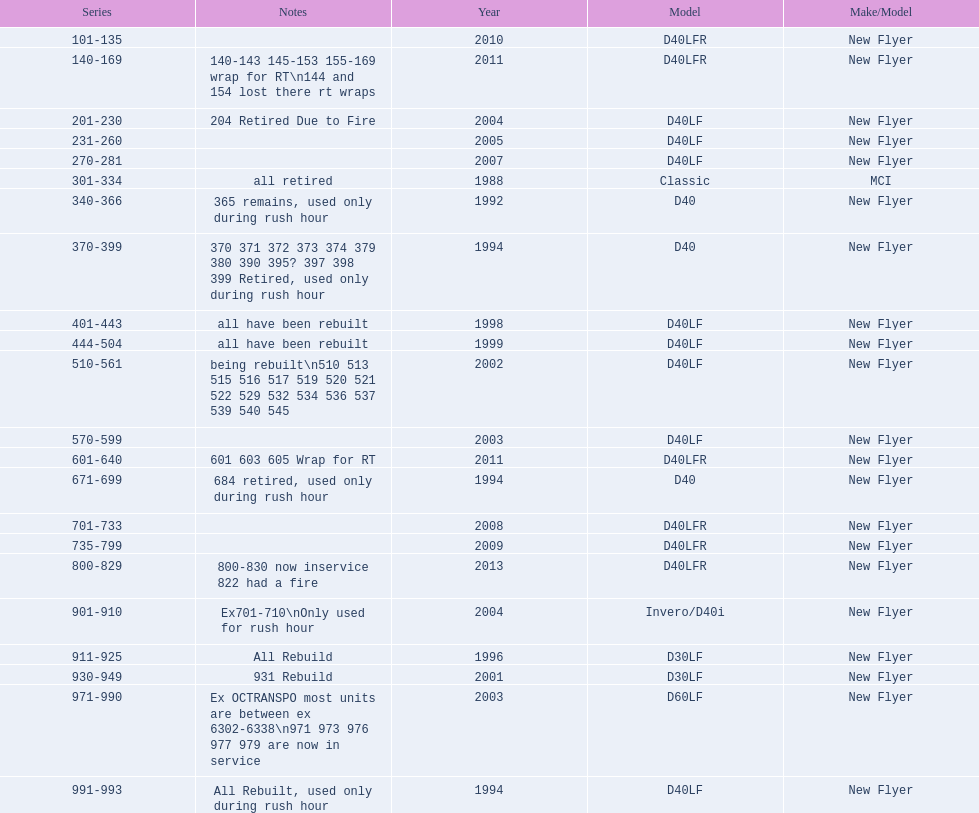What are all of the bus series numbers? 101-135, 140-169, 201-230, 231-260, 270-281, 301-334, 340-366, 370-399, 401-443, 444-504, 510-561, 570-599, 601-640, 671-699, 701-733, 735-799, 800-829, 901-910, 911-925, 930-949, 971-990, 991-993. When were they introduced? 2010, 2011, 2004, 2005, 2007, 1988, 1992, 1994, 1998, 1999, 2002, 2003, 2011, 1994, 2008, 2009, 2013, 2004, 1996, 2001, 2003, 1994. Which series is the newest? 800-829. Help me parse the entirety of this table. {'header': ['Series', 'Notes', 'Year', 'Model', 'Make/Model'], 'rows': [['101-135', '', '2010', 'D40LFR', 'New Flyer'], ['140-169', '140-143 145-153 155-169 wrap for RT\\n144 and 154 lost there rt wraps', '2011', 'D40LFR', 'New Flyer'], ['201-230', '204 Retired Due to Fire', '2004', 'D40LF', 'New Flyer'], ['231-260', '', '2005', 'D40LF', 'New Flyer'], ['270-281', '', '2007', 'D40LF', 'New Flyer'], ['301-334', 'all retired', '1988', 'Classic', 'MCI'], ['340-366', '365 remains, used only during rush hour', '1992', 'D40', 'New Flyer'], ['370-399', '370 371 372 373 374 379 380 390 395? 397 398 399 Retired, used only during rush hour', '1994', 'D40', 'New Flyer'], ['401-443', 'all have been rebuilt', '1998', 'D40LF', 'New Flyer'], ['444-504', 'all have been rebuilt', '1999', 'D40LF', 'New Flyer'], ['510-561', 'being rebuilt\\n510 513 515 516 517 519 520 521 522 529 532 534 536 537 539 540 545', '2002', 'D40LF', 'New Flyer'], ['570-599', '', '2003', 'D40LF', 'New Flyer'], ['601-640', '601 603 605 Wrap for RT', '2011', 'D40LFR', 'New Flyer'], ['671-699', '684 retired, used only during rush hour', '1994', 'D40', 'New Flyer'], ['701-733', '', '2008', 'D40LFR', 'New Flyer'], ['735-799', '', '2009', 'D40LFR', 'New Flyer'], ['800-829', '800-830 now inservice 822 had a fire', '2013', 'D40LFR', 'New Flyer'], ['901-910', 'Ex701-710\\nOnly used for rush hour', '2004', 'Invero/D40i', 'New Flyer'], ['911-925', 'All Rebuild', '1996', 'D30LF', 'New Flyer'], ['930-949', '931 Rebuild', '2001', 'D30LF', 'New Flyer'], ['971-990', 'Ex OCTRANSPO most units are between ex 6302-6338\\n971 973 976 977 979 are now in service', '2003', 'D60LF', 'New Flyer'], ['991-993', 'All Rebuilt, used only during rush hour', '1994', 'D40LF', 'New Flyer']]} 